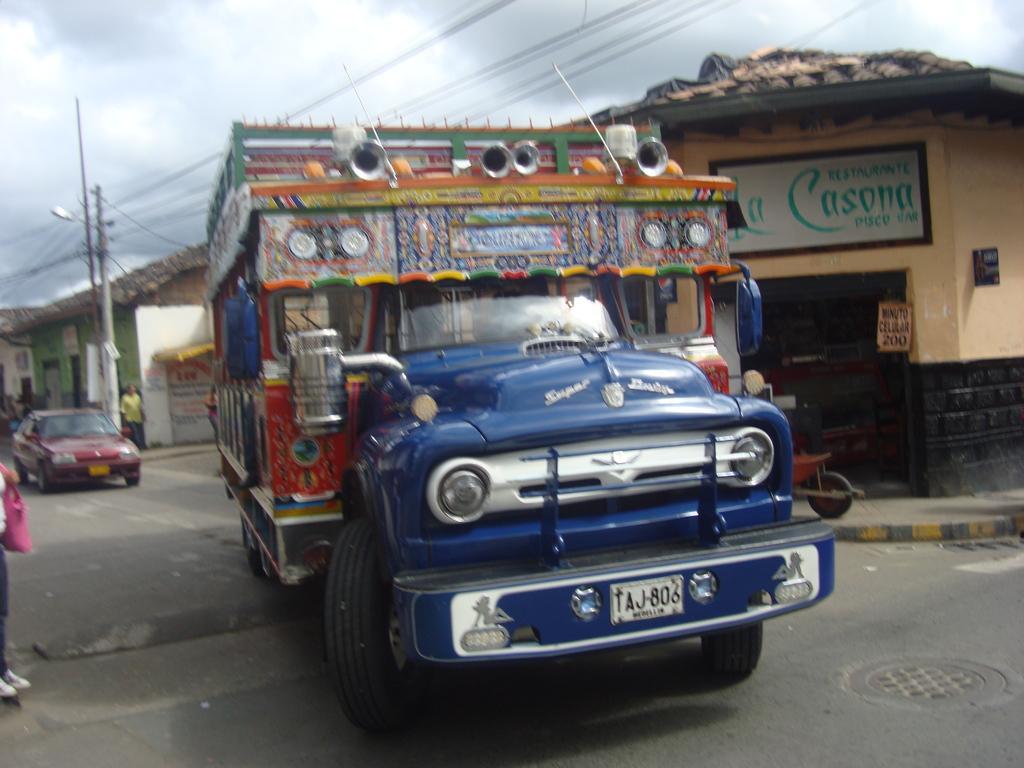In one or two sentences, can you explain what this image depicts? There is a vehicle in the center of the image, there are people, it seems like houses, vehicle, poles, wires and the sky in the background. 